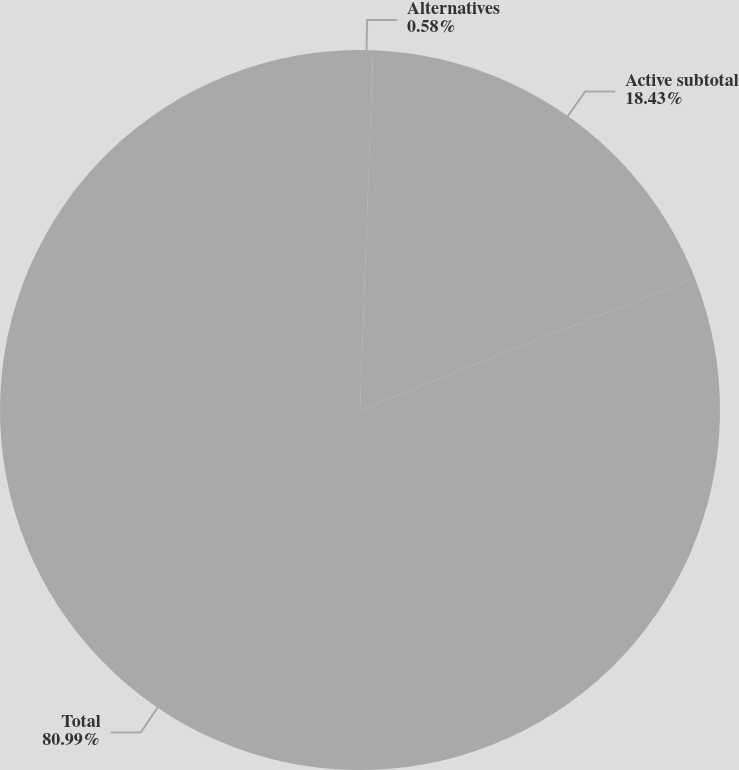Convert chart to OTSL. <chart><loc_0><loc_0><loc_500><loc_500><pie_chart><fcel>Alternatives<fcel>Active subtotal<fcel>Total<nl><fcel>0.58%<fcel>18.43%<fcel>80.99%<nl></chart> 